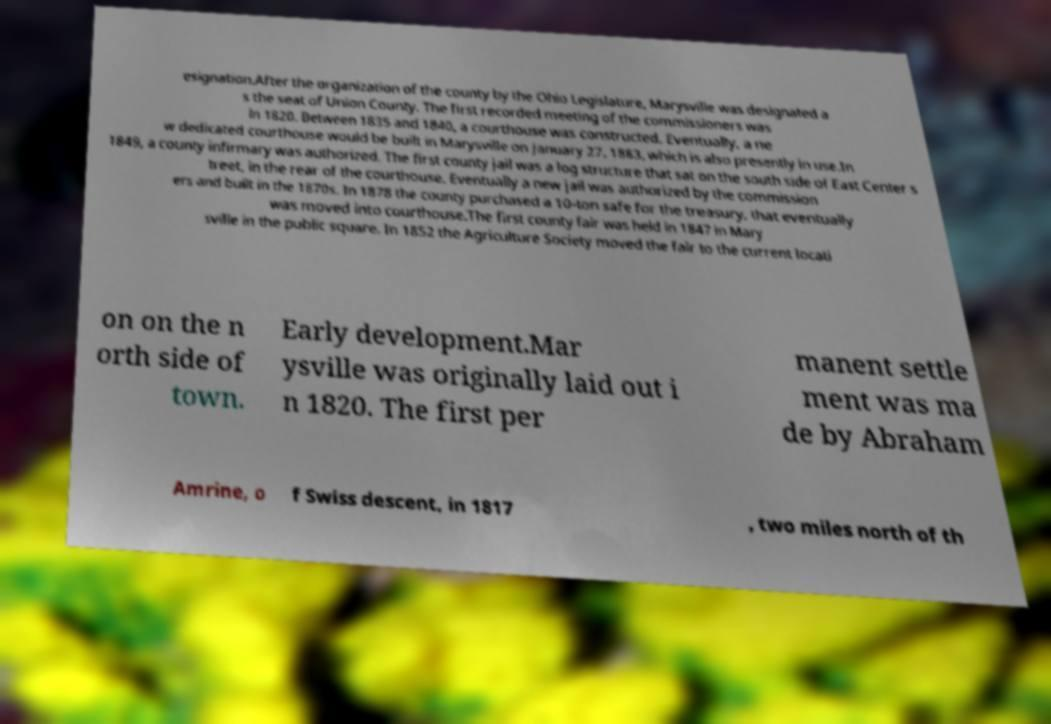Could you extract and type out the text from this image? esignation.After the organization of the county by the Ohio Legislature, Marysville was designated a s the seat of Union County. The first recorded meeting of the commissioners was in 1820. Between 1835 and 1840, a courthouse was constructed. Eventually, a ne w dedicated courthouse would be built in Marysville on January 27, 1883, which is also presently in use.In 1849, a county infirmary was authorized. The first county jail was a log structure that sat on the south side of East Center s treet, in the rear of the courthouse. Eventually a new jail was authorized by the commission ers and built in the 1870s. In 1878 the county purchased a 10-ton safe for the treasury, that eventually was moved into courthouse.The first county fair was held in 1847 in Mary sville in the public square. In 1852 the Agriculture Society moved the fair to the current locati on on the n orth side of town. Early development.Mar ysville was originally laid out i n 1820. The first per manent settle ment was ma de by Abraham Amrine, o f Swiss descent, in 1817 , two miles north of th 